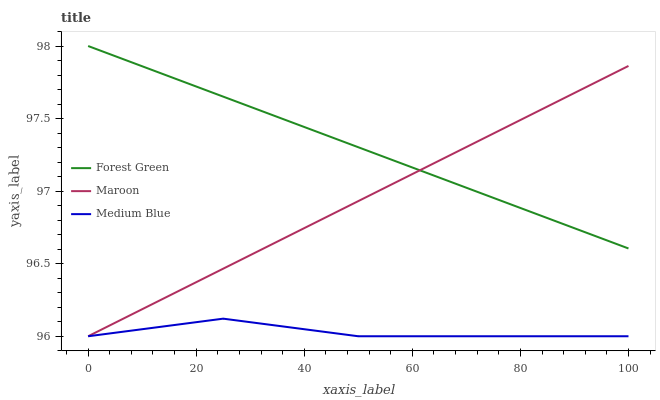Does Medium Blue have the minimum area under the curve?
Answer yes or no. Yes. Does Forest Green have the maximum area under the curve?
Answer yes or no. Yes. Does Maroon have the minimum area under the curve?
Answer yes or no. No. Does Maroon have the maximum area under the curve?
Answer yes or no. No. Is Forest Green the smoothest?
Answer yes or no. Yes. Is Medium Blue the roughest?
Answer yes or no. Yes. Is Maroon the smoothest?
Answer yes or no. No. Is Maroon the roughest?
Answer yes or no. No. Does Medium Blue have the lowest value?
Answer yes or no. Yes. Does Forest Green have the highest value?
Answer yes or no. Yes. Does Maroon have the highest value?
Answer yes or no. No. Is Medium Blue less than Forest Green?
Answer yes or no. Yes. Is Forest Green greater than Medium Blue?
Answer yes or no. Yes. Does Forest Green intersect Maroon?
Answer yes or no. Yes. Is Forest Green less than Maroon?
Answer yes or no. No. Is Forest Green greater than Maroon?
Answer yes or no. No. Does Medium Blue intersect Forest Green?
Answer yes or no. No. 